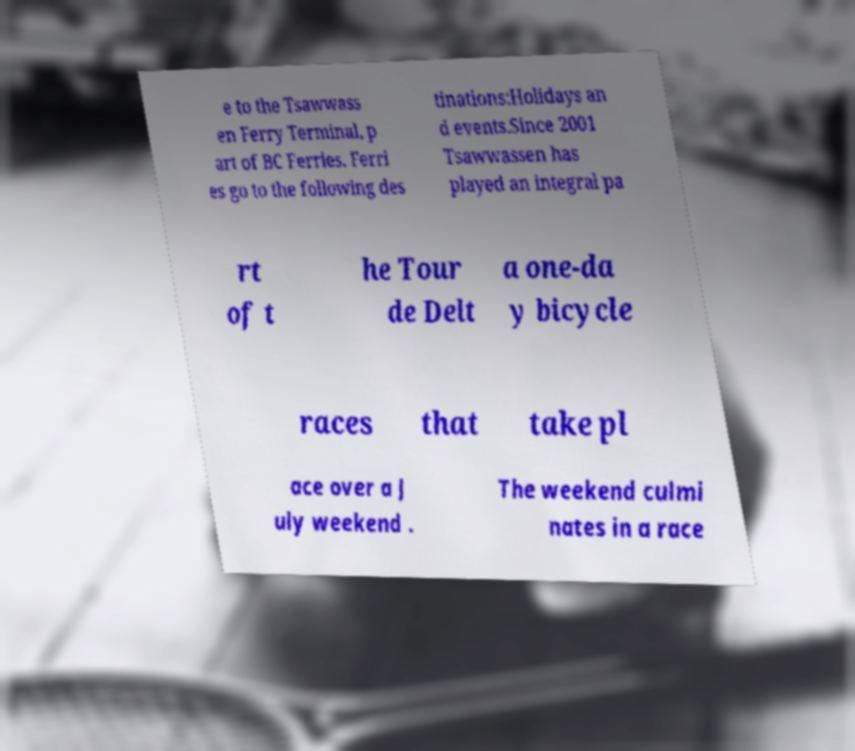What messages or text are displayed in this image? I need them in a readable, typed format. e to the Tsawwass en Ferry Terminal, p art of BC Ferries. Ferri es go to the following des tinations:Holidays an d events.Since 2001 Tsawwassen has played an integral pa rt of t he Tour de Delt a one-da y bicycle races that take pl ace over a J uly weekend . The weekend culmi nates in a race 